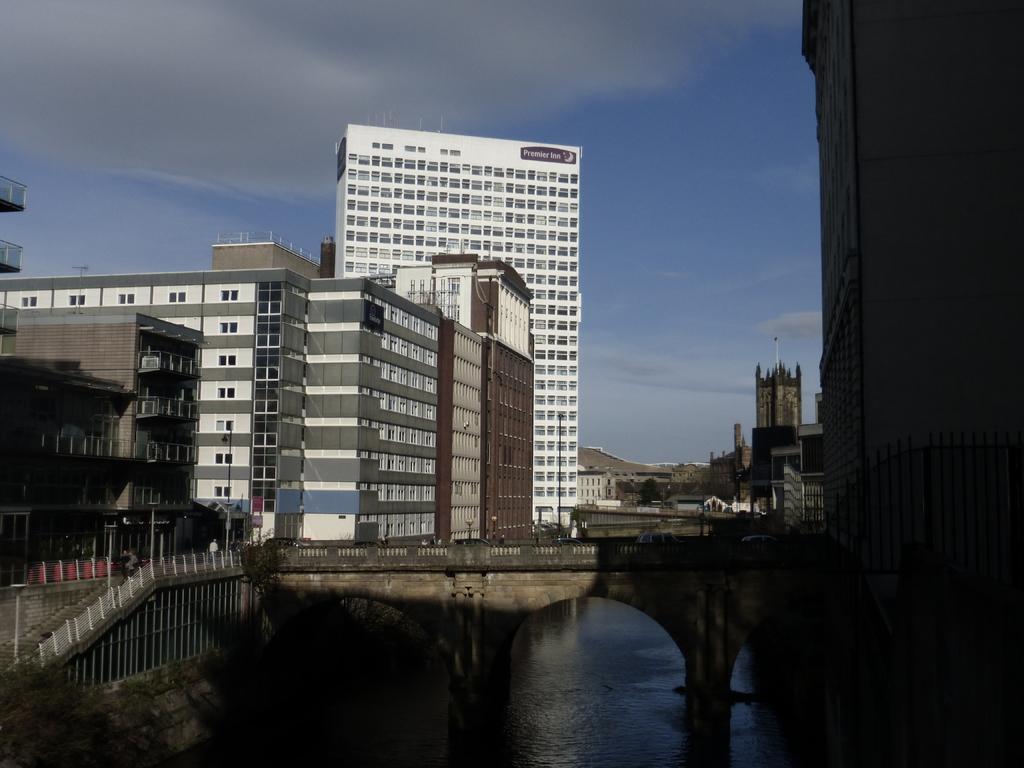Please provide a concise description of this image. In this image we can see the buildings, stairs, railing and also the bridge. In the background we can the sky with some clouds. At the bottom we can see the water. 